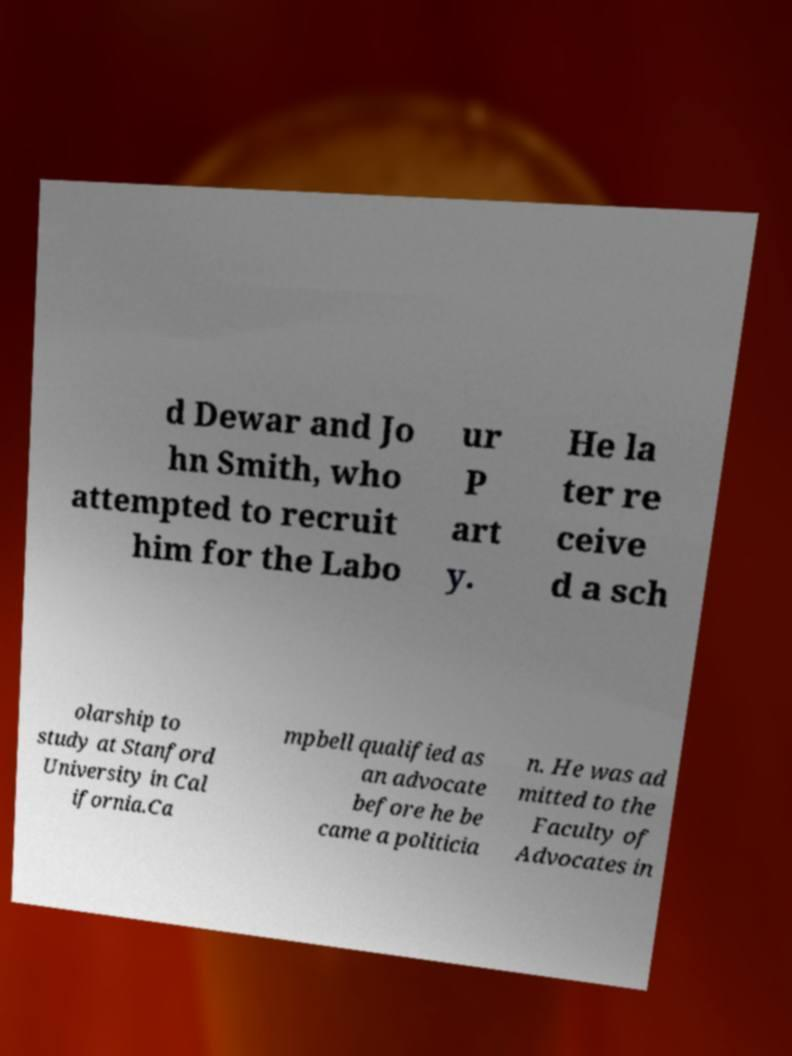What messages or text are displayed in this image? I need them in a readable, typed format. d Dewar and Jo hn Smith, who attempted to recruit him for the Labo ur P art y. He la ter re ceive d a sch olarship to study at Stanford University in Cal ifornia.Ca mpbell qualified as an advocate before he be came a politicia n. He was ad mitted to the Faculty of Advocates in 